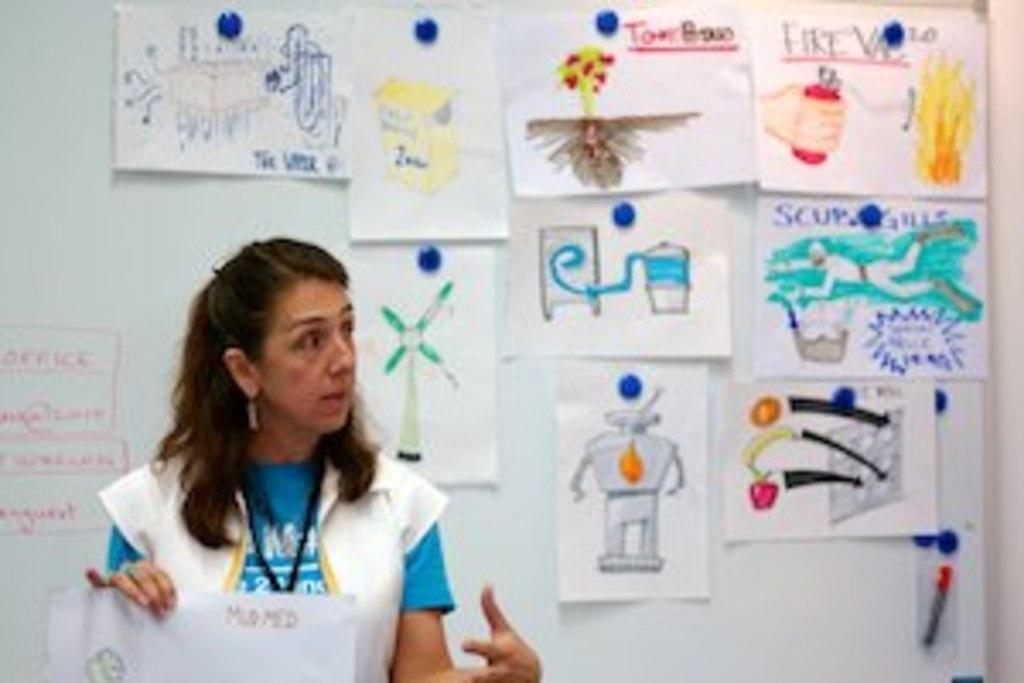How would you summarize this image in a sentence or two? In this image there is a woman standing, holding a paper in her hand, in the background there is a wall, for that wall there are papers, on that papers there are some pictures. 